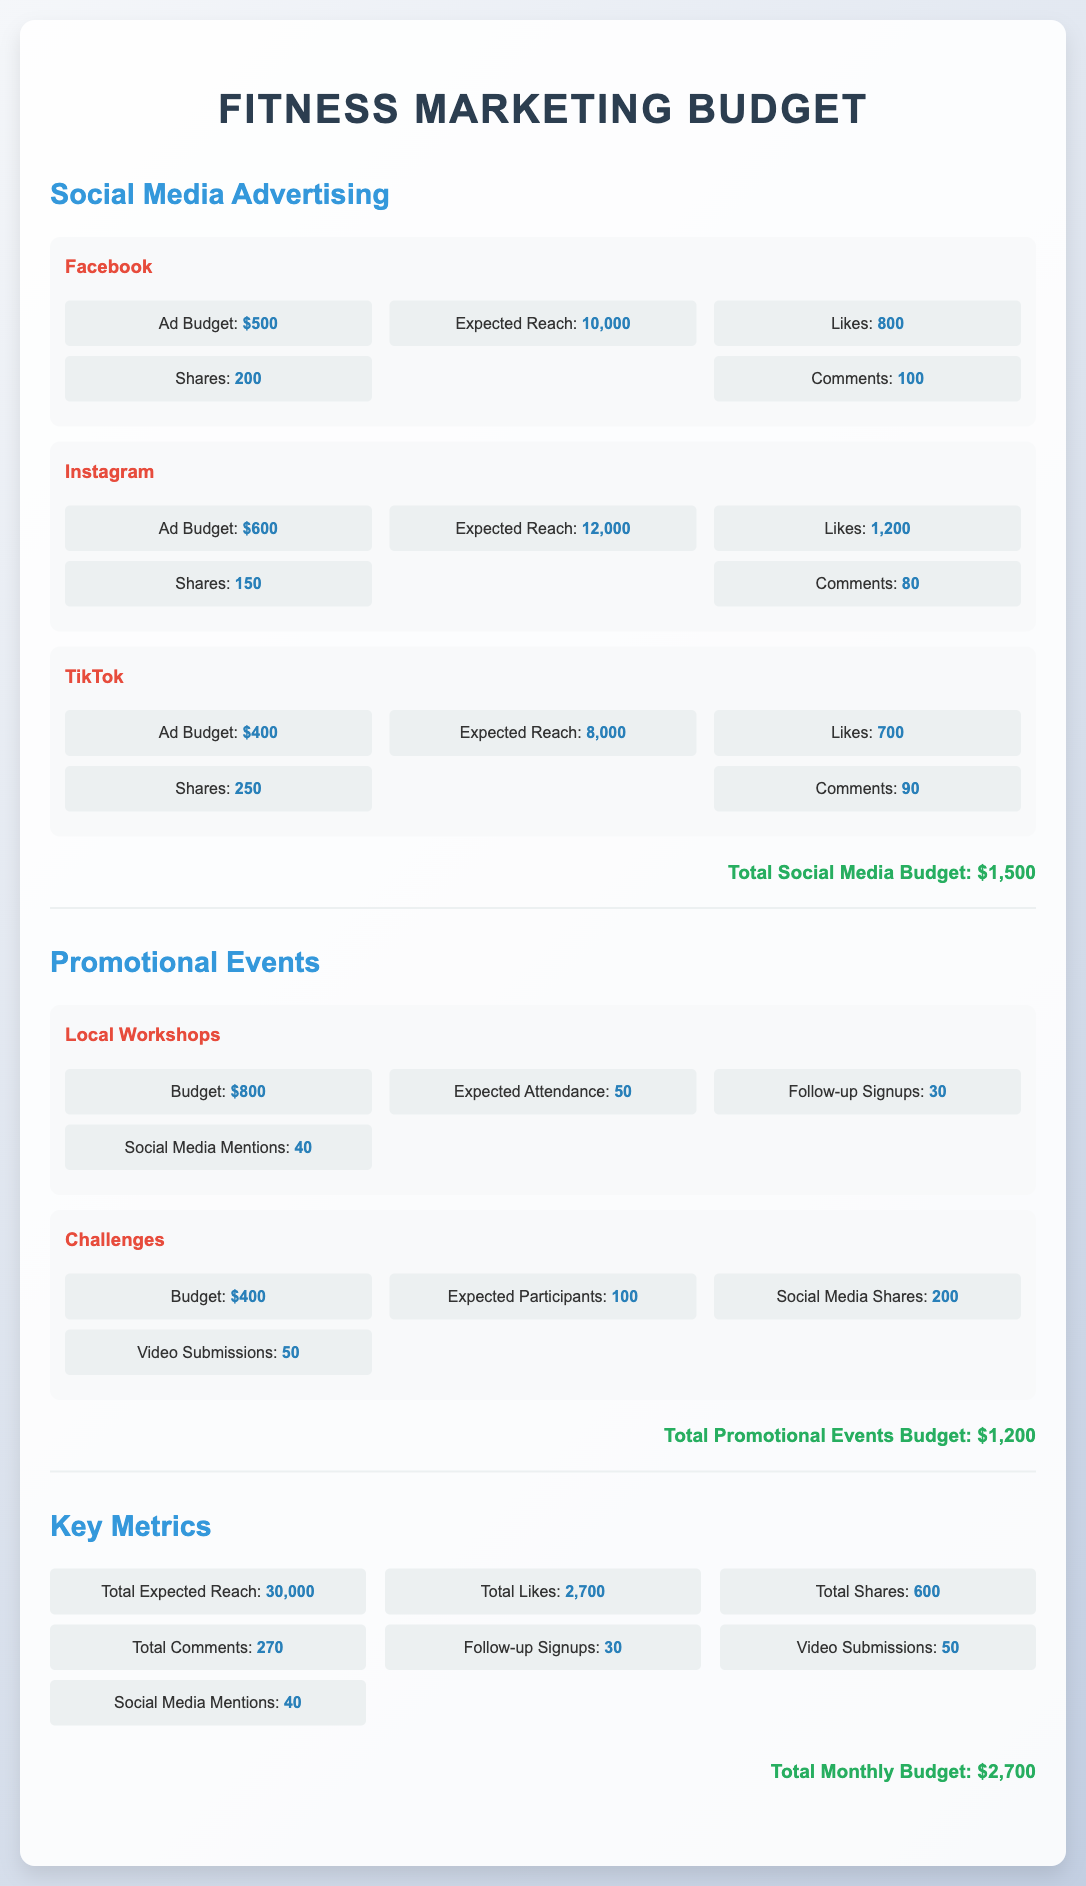What is the total ad budget for social media? The total ad budget for social media is the sum of all individual platform budgets: $500 + $600 + $400 = $1500.
Answer: $1500 What is the expected reach for Instagram? The expected reach for Instagram is specifically stated in the document as 12,000.
Answer: 12,000 How many likes are expected from TikTok ads? The expected number of likes from TikTok ads is mentioned in the document as 700.
Answer: 700 What is the budget allocated for local workshops? The budget for local workshops is detailed in the document as $800.
Answer: $800 What is the total expected reach from all promotional events? The total expected reach from promotional events can be inferred as part of the overall metrics: 30,000.
Answer: 30,000 How many social media mentions are expected from local workshops? The document specifies that local workshops will lead to an expected 40 social media mentions.
Answer: 40 What is the total budget for promotional events? The total budget for promotional events is calculated from both local workshops and challenges: $800 + $400 = $1200.
Answer: $1,200 How many participants are expected in the challenges? The expected participants in the challenges are explicitly stated as 100 in the document.
Answer: 100 What is the total monthly budget for the marketing initiatives? The document sums up all budgets, resulting in a total monthly budget of $2,700.
Answer: $2,700 